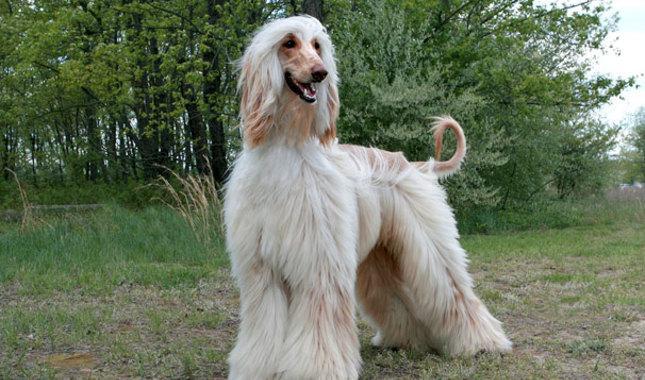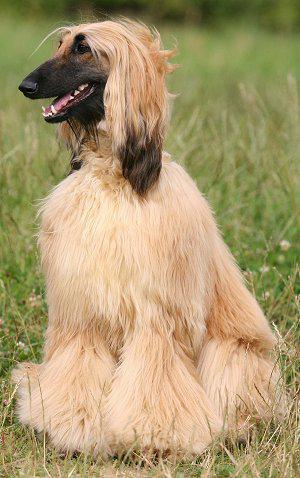The first image is the image on the left, the second image is the image on the right. Assess this claim about the two images: "All the dogs pictured are standing on the grass.". Correct or not? Answer yes or no. No. 